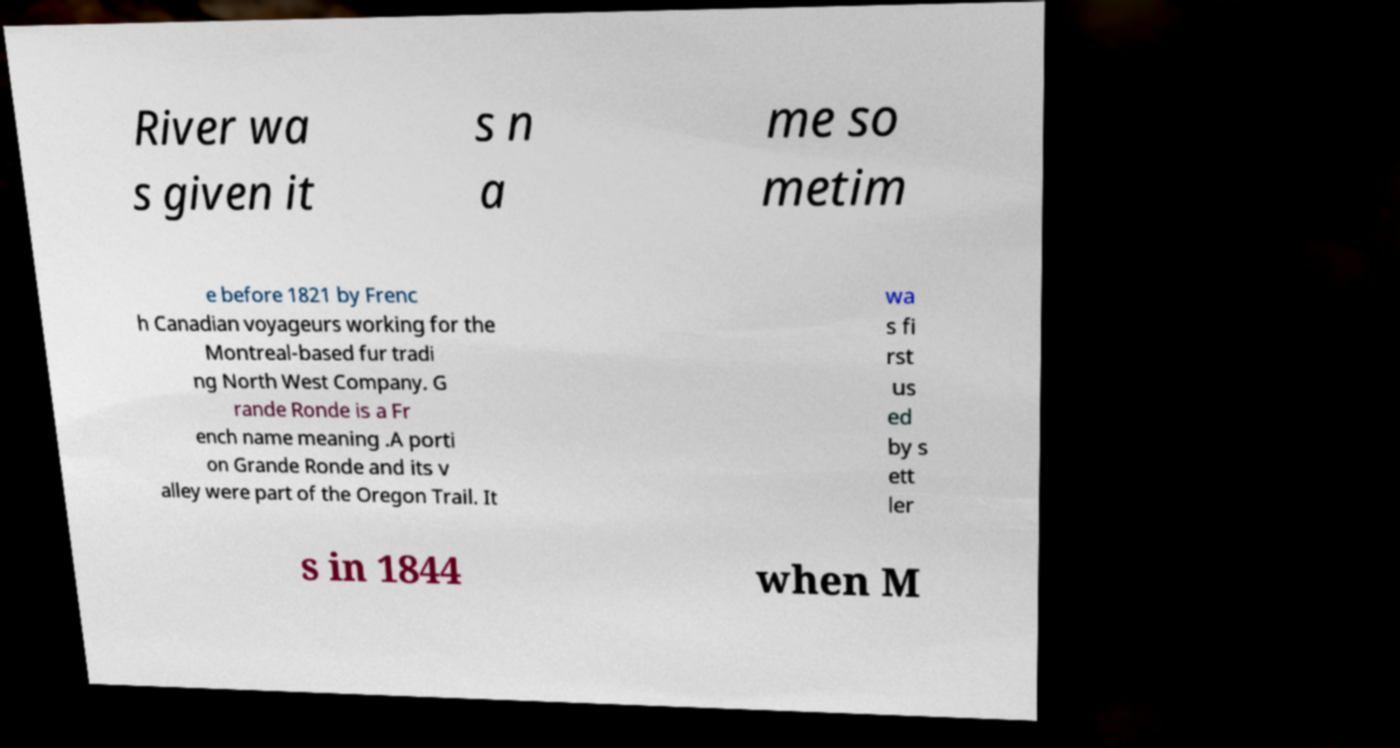Can you read and provide the text displayed in the image?This photo seems to have some interesting text. Can you extract and type it out for me? River wa s given it s n a me so metim e before 1821 by Frenc h Canadian voyageurs working for the Montreal-based fur tradi ng North West Company. G rande Ronde is a Fr ench name meaning .A porti on Grande Ronde and its v alley were part of the Oregon Trail. It wa s fi rst us ed by s ett ler s in 1844 when M 